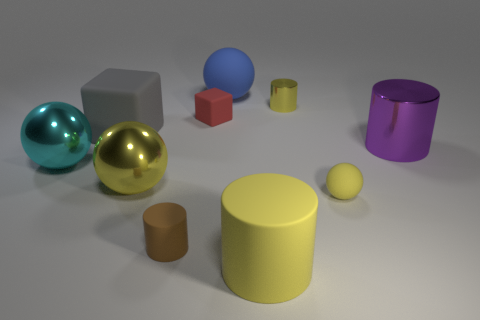Subtract 1 balls. How many balls are left? 3 Subtract all red cylinders. Subtract all purple balls. How many cylinders are left? 4 Subtract all cylinders. How many objects are left? 6 Subtract 0 gray balls. How many objects are left? 10 Subtract all big brown spheres. Subtract all tiny brown matte cylinders. How many objects are left? 9 Add 9 tiny yellow metal objects. How many tiny yellow metal objects are left? 10 Add 8 gray objects. How many gray objects exist? 9 